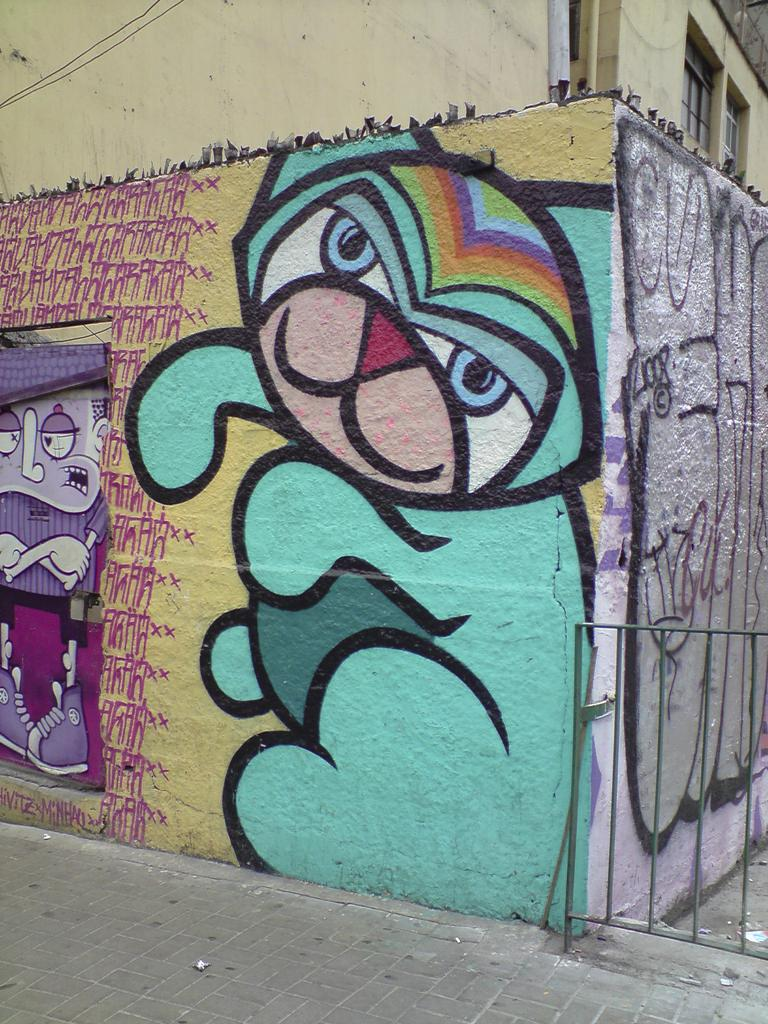What type of artwork can be seen on the wall and gate in the image? There is graffiti on the wall and gate in the image. What other architectural features are visible in the image? There are windows visible in the image. What else can be seen in the image besides the graffiti and windows? Wires and a pole are present in the image. What type of cast can be seen on the pole in the image? There is no cast present on the pole in the image. What type of beef is being cooked on the windows in the image? There is no beef or cooking activity visible in the image; it only features graffiti, windows, wires, and a pole. 